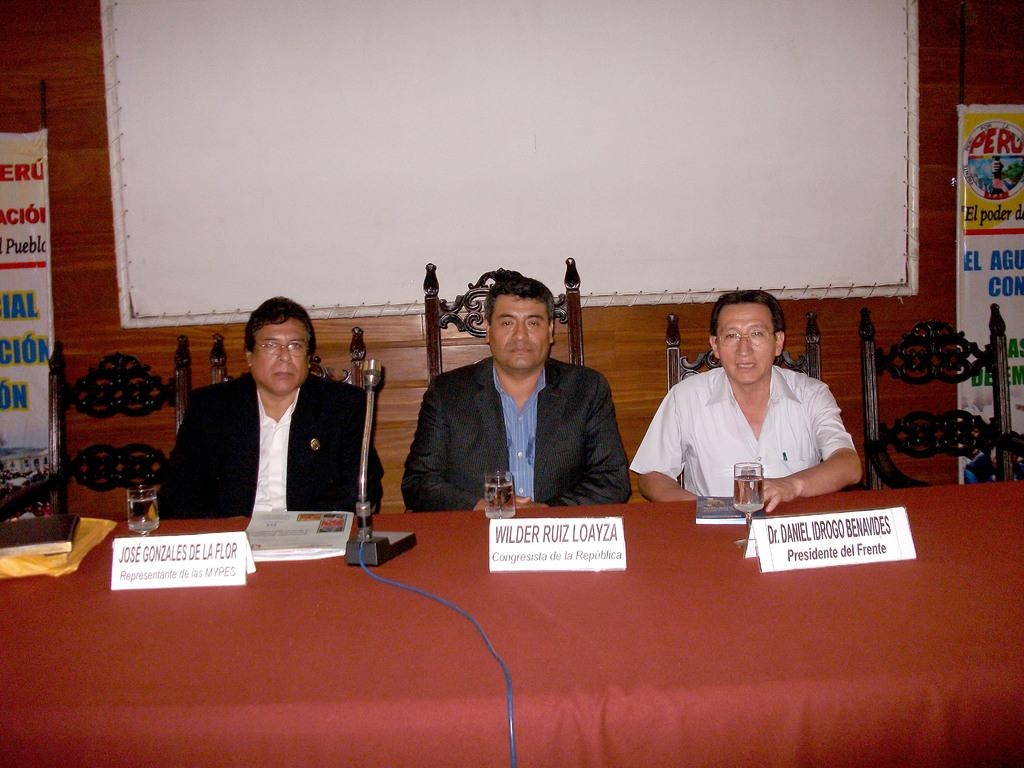<image>
Share a concise interpretation of the image provided. A representative, a congressman and a president sit at a conference table. 